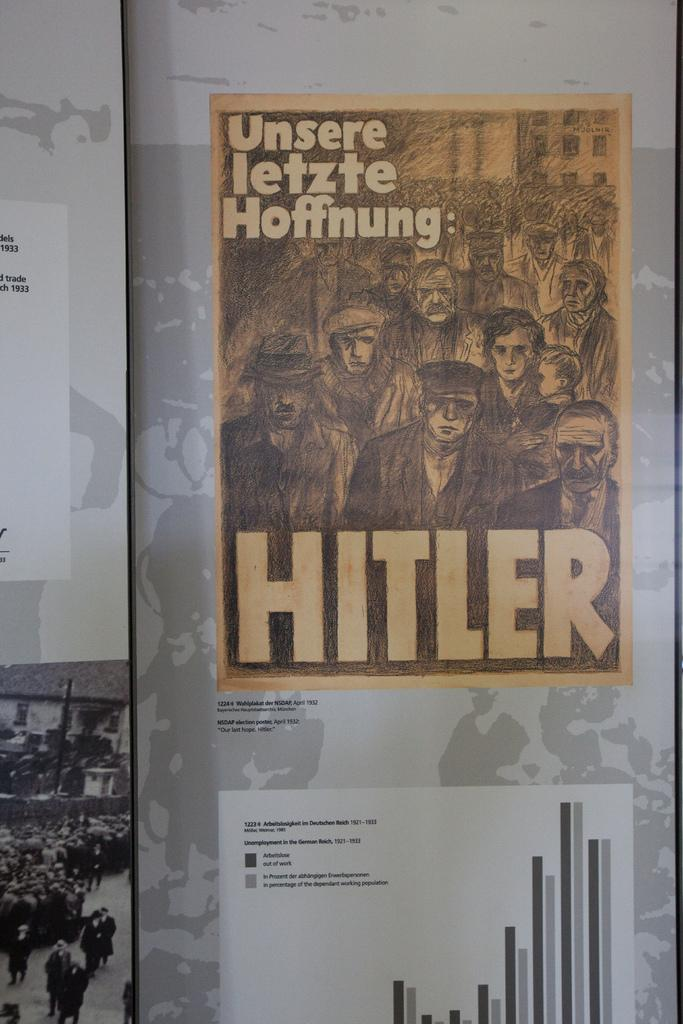<image>
Provide a brief description of the given image. Poster hung that show Hitler and graphs that german people were included in. 